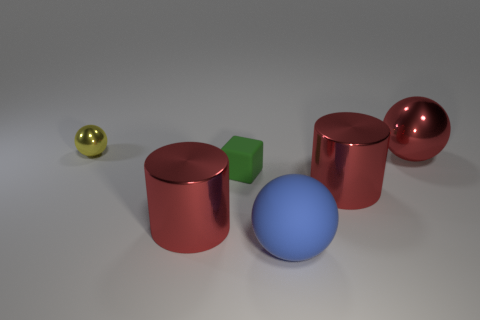Are any balls visible?
Provide a short and direct response. Yes. What is the color of the other big metallic thing that is the same shape as the yellow thing?
Provide a succinct answer. Red. What is the color of the object that is the same size as the green rubber block?
Your answer should be very brief. Yellow. Is the material of the small yellow thing the same as the large blue object?
Ensure brevity in your answer.  No. What number of matte cubes have the same color as the tiny sphere?
Provide a succinct answer. 0. Do the matte sphere and the rubber block have the same color?
Your answer should be very brief. No. There is a tiny object that is in front of the yellow metallic sphere; what is its material?
Your answer should be very brief. Rubber. What number of big objects are red metal balls or yellow spheres?
Your answer should be compact. 1. Is there a brown cube that has the same material as the tiny yellow object?
Your answer should be compact. No. Do the metal cylinder right of the blue matte ball and the small cube have the same size?
Your response must be concise. No. 